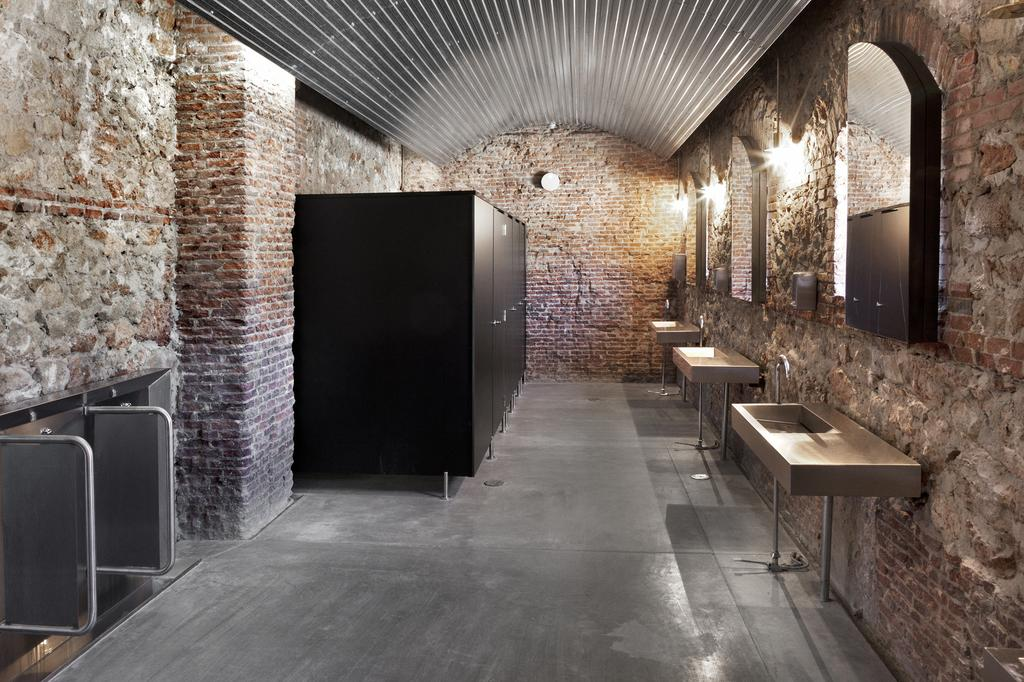What type of room is depicted in the image? The image is of a washroom. What can be seen on the right side of the washroom? There are windows, mirrors, a sink, taps, and pipes on the right side of the washroom. What is located on the left side of the washroom? There are basins, doors, and a light on the left side of the washroom. What is the wall made of in the washroom? There is a brick wall in the washroom. How many fingers can be seen holding a kite in the image? There is no kite or fingers holding a kite present in the image. 